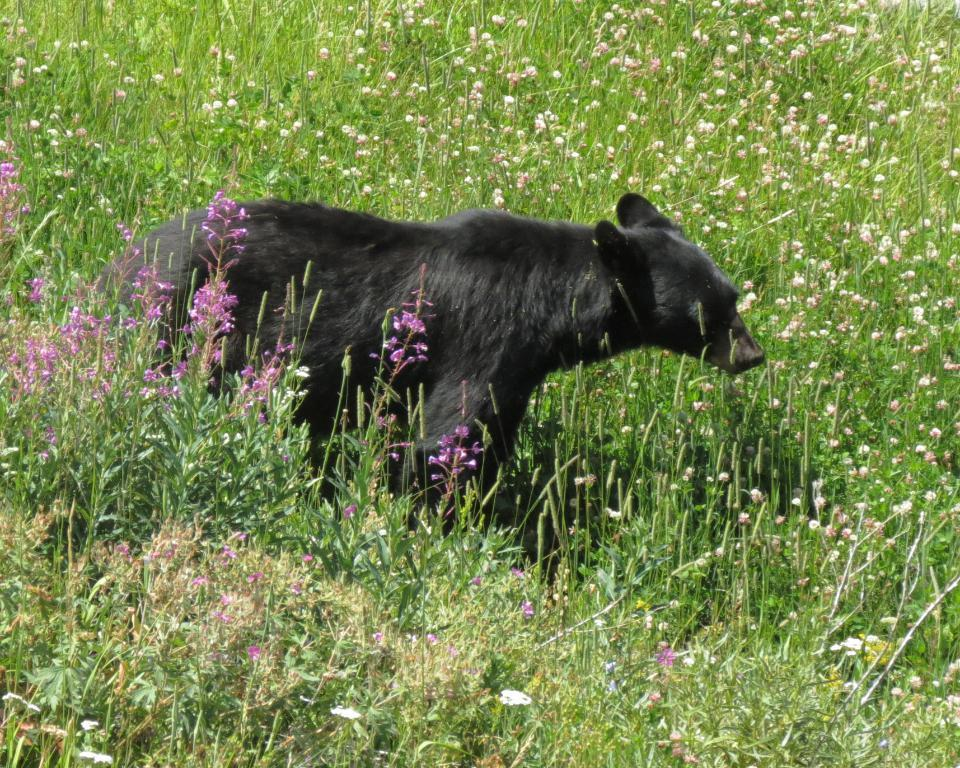What type of creature is in the image? There is an animal in the image. Where is the animal located? The animal is standing on the grass. What is the grass situated on? The grass is on the ground. What other types of plants can be seen in the image? There are small plants with flowers in the image. How does the animal express pain in the image? There is no indication of pain in the image; the animal is simply standing on the grass. What shape is the ocean in the image? There is no ocean present in the image. 